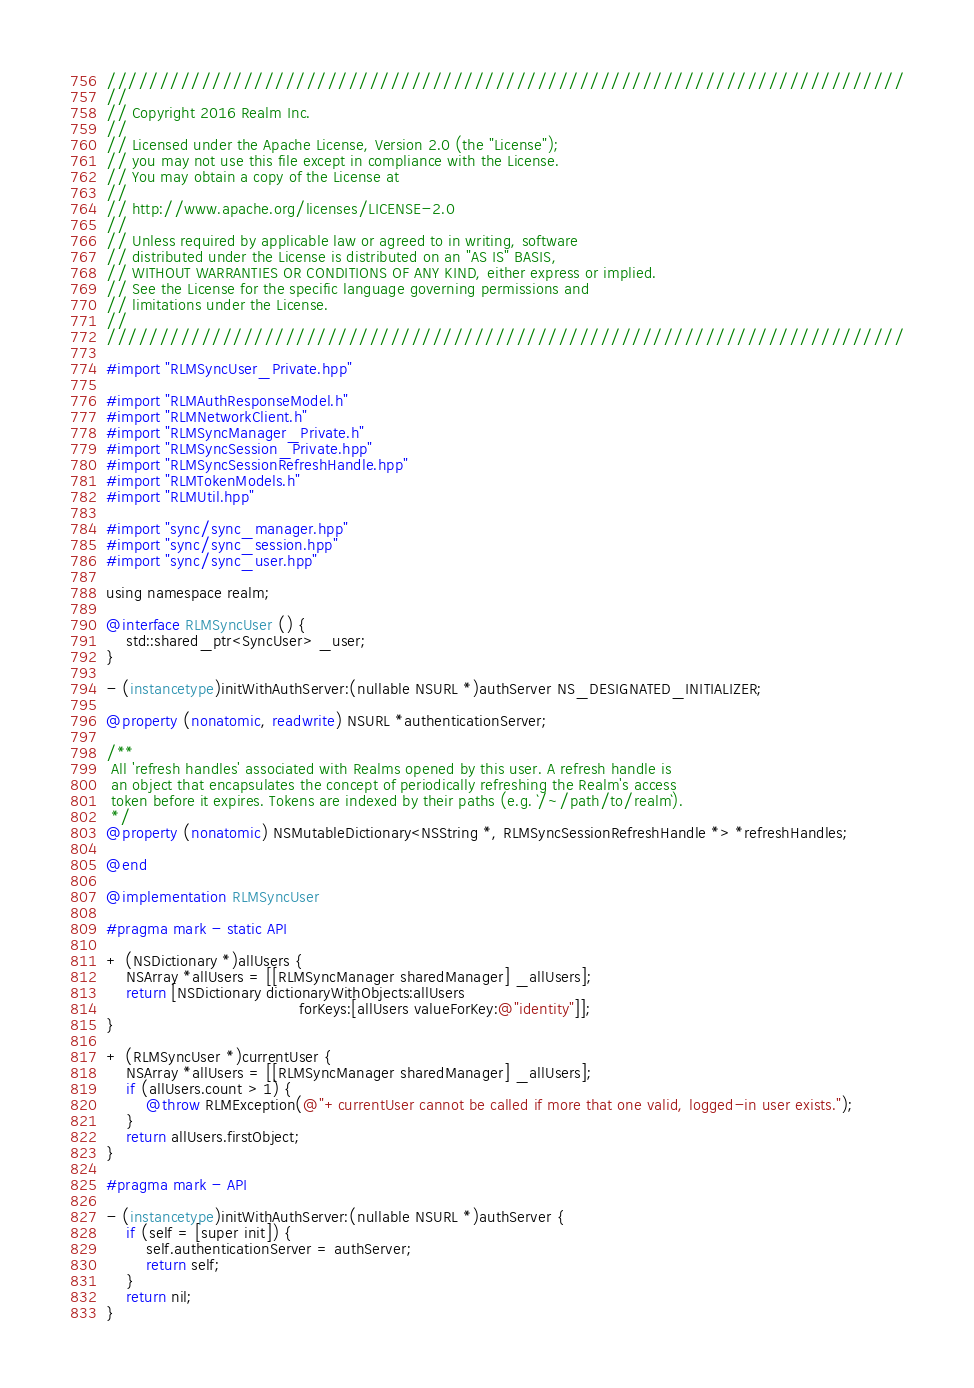Convert code to text. <code><loc_0><loc_0><loc_500><loc_500><_ObjectiveC_>////////////////////////////////////////////////////////////////////////////
//
// Copyright 2016 Realm Inc.
//
// Licensed under the Apache License, Version 2.0 (the "License");
// you may not use this file except in compliance with the License.
// You may obtain a copy of the License at
//
// http://www.apache.org/licenses/LICENSE-2.0
//
// Unless required by applicable law or agreed to in writing, software
// distributed under the License is distributed on an "AS IS" BASIS,
// WITHOUT WARRANTIES OR CONDITIONS OF ANY KIND, either express or implied.
// See the License for the specific language governing permissions and
// limitations under the License.
//
////////////////////////////////////////////////////////////////////////////

#import "RLMSyncUser_Private.hpp"

#import "RLMAuthResponseModel.h"
#import "RLMNetworkClient.h"
#import "RLMSyncManager_Private.h"
#import "RLMSyncSession_Private.hpp"
#import "RLMSyncSessionRefreshHandle.hpp"
#import "RLMTokenModels.h"
#import "RLMUtil.hpp"

#import "sync/sync_manager.hpp"
#import "sync/sync_session.hpp"
#import "sync/sync_user.hpp"

using namespace realm;

@interface RLMSyncUser () {
    std::shared_ptr<SyncUser> _user;
}

- (instancetype)initWithAuthServer:(nullable NSURL *)authServer NS_DESIGNATED_INITIALIZER;

@property (nonatomic, readwrite) NSURL *authenticationServer;

/**
 All 'refresh handles' associated with Realms opened by this user. A refresh handle is
 an object that encapsulates the concept of periodically refreshing the Realm's access
 token before it expires. Tokens are indexed by their paths (e.g. `/~/path/to/realm`).
 */
@property (nonatomic) NSMutableDictionary<NSString *, RLMSyncSessionRefreshHandle *> *refreshHandles;

@end

@implementation RLMSyncUser

#pragma mark - static API

+ (NSDictionary *)allUsers {
    NSArray *allUsers = [[RLMSyncManager sharedManager] _allUsers];
    return [NSDictionary dictionaryWithObjects:allUsers
                                       forKeys:[allUsers valueForKey:@"identity"]];
}

+ (RLMSyncUser *)currentUser {
    NSArray *allUsers = [[RLMSyncManager sharedManager] _allUsers];
    if (allUsers.count > 1) {
        @throw RLMException(@"+currentUser cannot be called if more that one valid, logged-in user exists.");
    }
    return allUsers.firstObject;
}

#pragma mark - API

- (instancetype)initWithAuthServer:(nullable NSURL *)authServer {
    if (self = [super init]) {
        self.authenticationServer = authServer;
        return self;
    }
    return nil;
}
</code> 